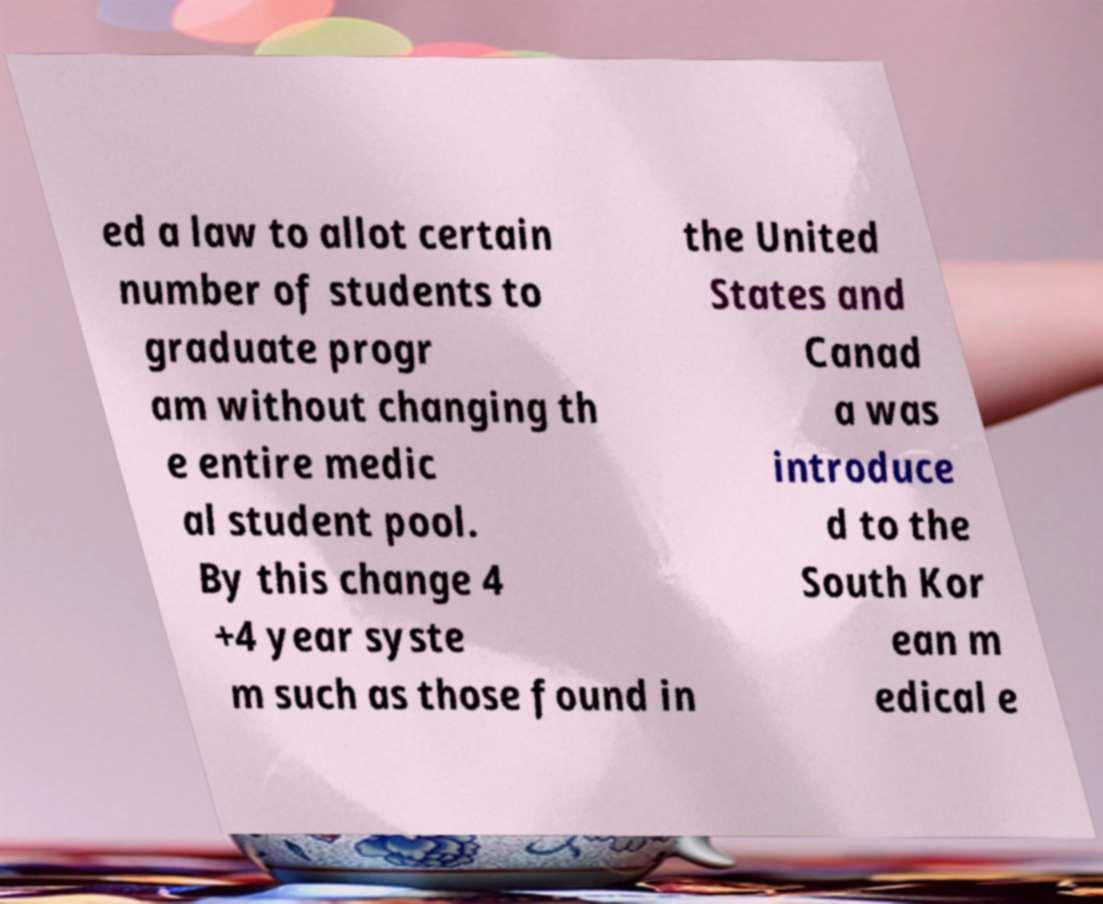Please read and relay the text visible in this image. What does it say? ed a law to allot certain number of students to graduate progr am without changing th e entire medic al student pool. By this change 4 +4 year syste m such as those found in the United States and Canad a was introduce d to the South Kor ean m edical e 